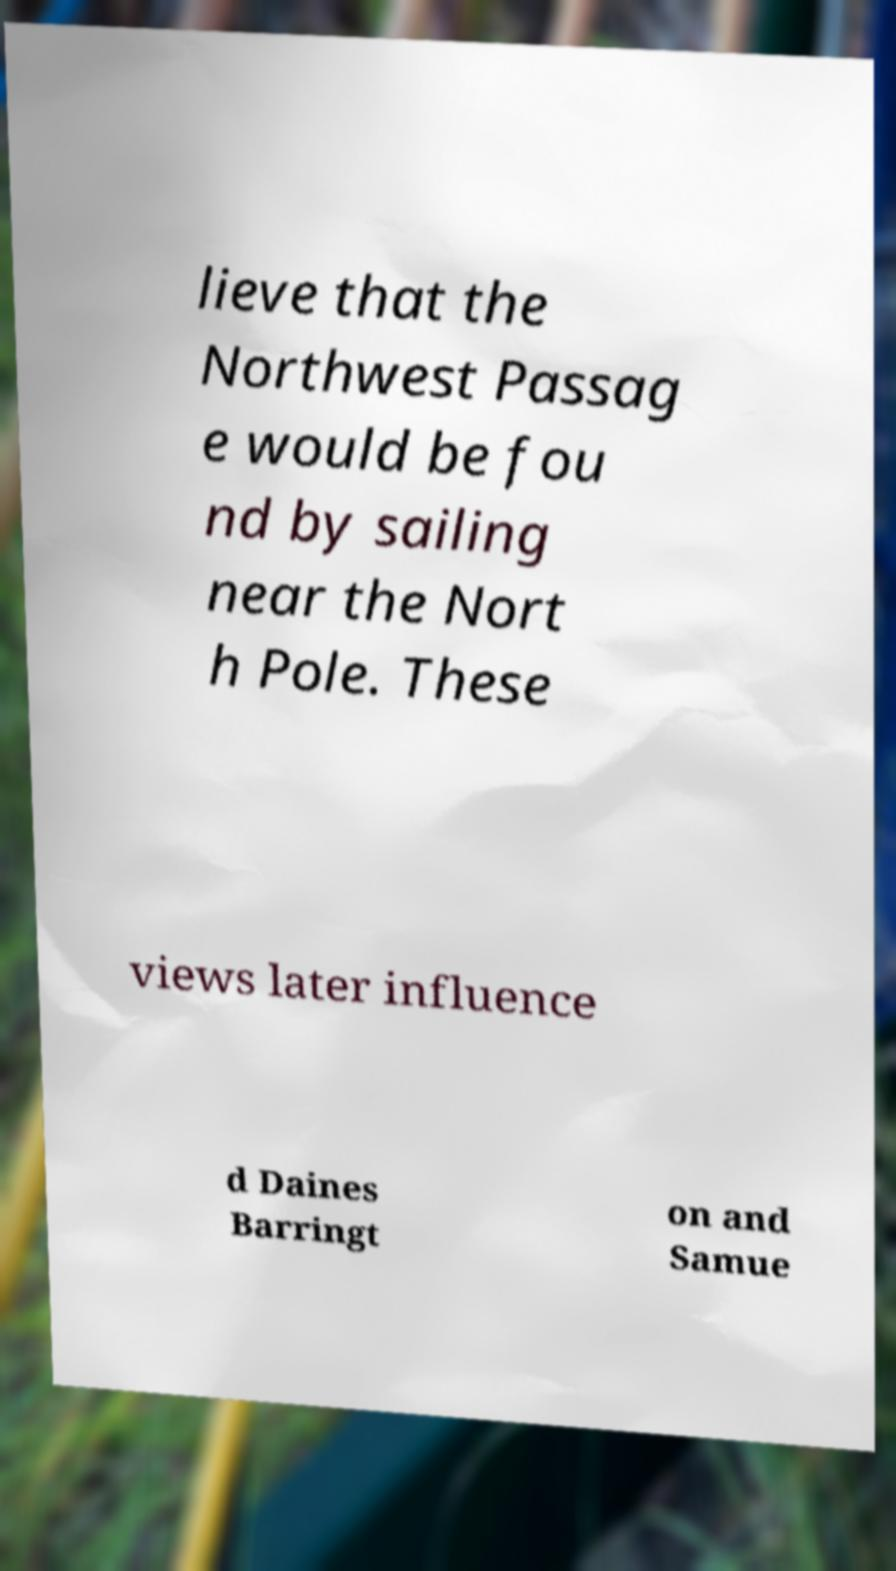Could you assist in decoding the text presented in this image and type it out clearly? lieve that the Northwest Passag e would be fou nd by sailing near the Nort h Pole. These views later influence d Daines Barringt on and Samue 